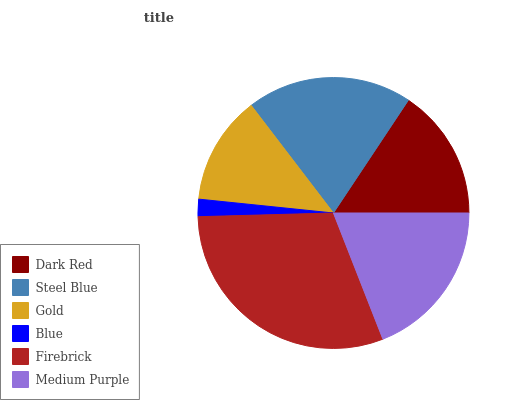Is Blue the minimum?
Answer yes or no. Yes. Is Firebrick the maximum?
Answer yes or no. Yes. Is Steel Blue the minimum?
Answer yes or no. No. Is Steel Blue the maximum?
Answer yes or no. No. Is Steel Blue greater than Dark Red?
Answer yes or no. Yes. Is Dark Red less than Steel Blue?
Answer yes or no. Yes. Is Dark Red greater than Steel Blue?
Answer yes or no. No. Is Steel Blue less than Dark Red?
Answer yes or no. No. Is Medium Purple the high median?
Answer yes or no. Yes. Is Dark Red the low median?
Answer yes or no. Yes. Is Steel Blue the high median?
Answer yes or no. No. Is Firebrick the low median?
Answer yes or no. No. 